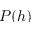<formula> <loc_0><loc_0><loc_500><loc_500>P ( h )</formula> 